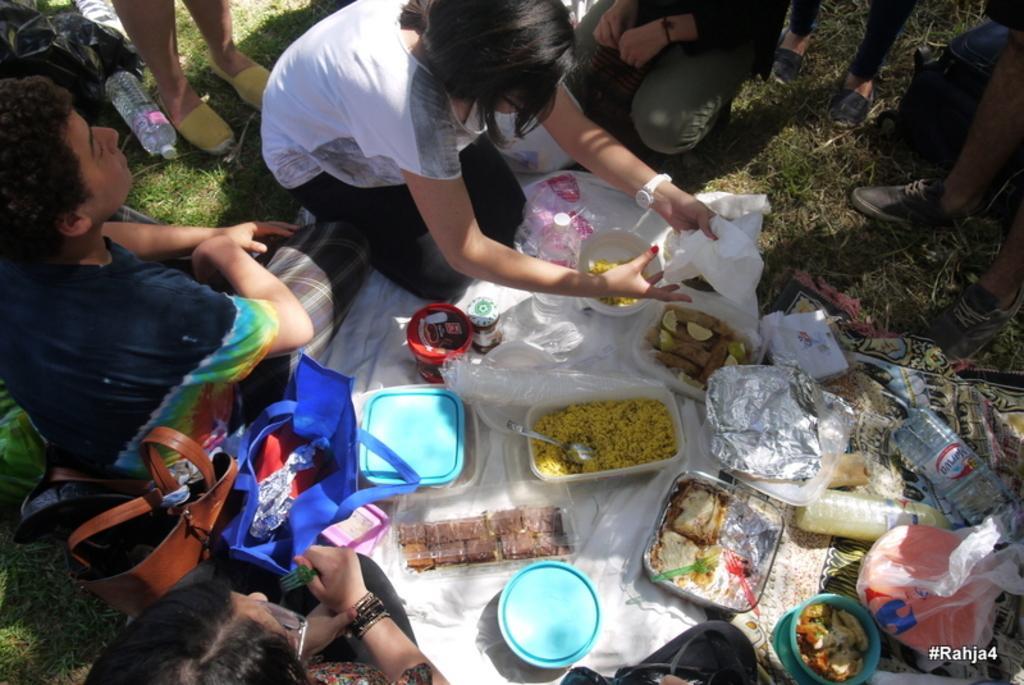Could you give a brief overview of what you see in this image? In the image few people are sitting and standing and there are some bags and boxes and food items and there are some covers and there is grass. 